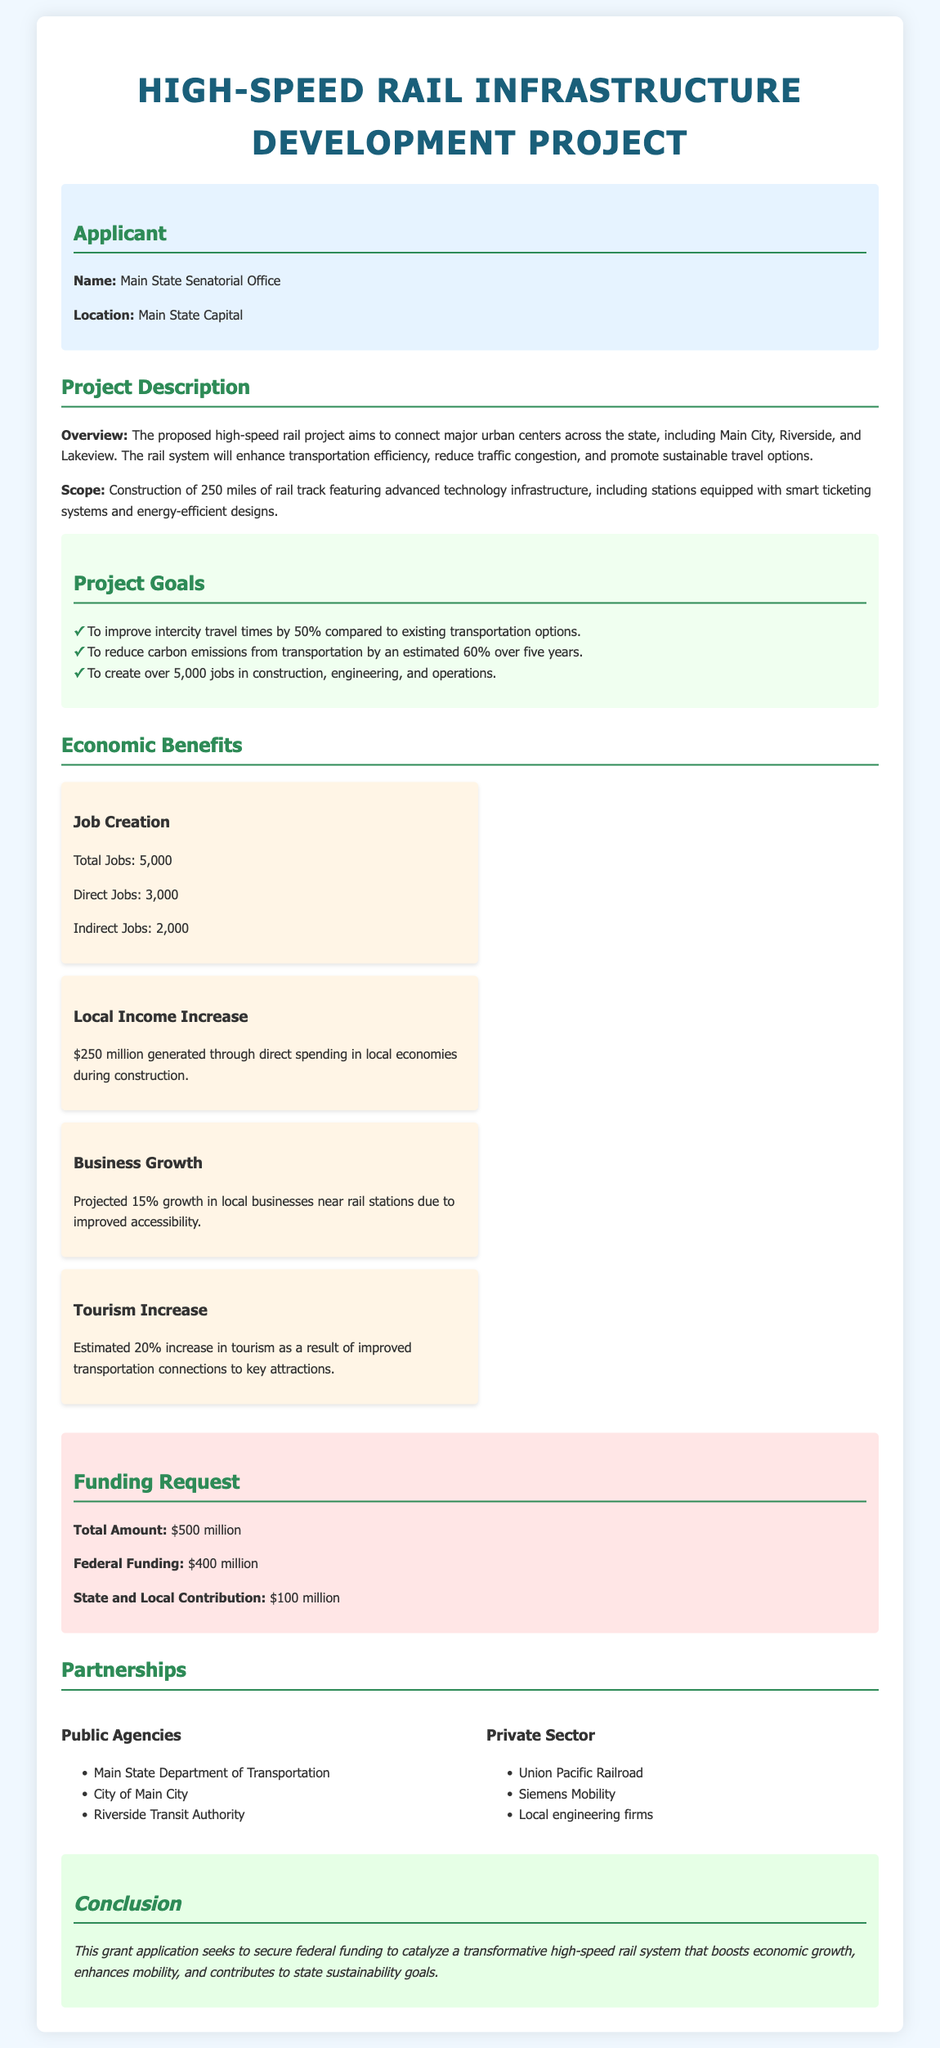What is the name of the applicant? The applicant's name is provided in the document as "Main State Senatorial Office."
Answer: Main State Senatorial Office What is the total funding requested? The total amount requested for the project is clearly stated in the document.
Answer: $500 million How many miles of rail track are proposed to be constructed? The document states the scope of construction involves 250 miles of rail track.
Answer: 250 miles What percentage increase in tourism is estimated? The document indicates an estimated 20% increase in tourism due to the project.
Answer: 20% Which public agency is involved in the project? The document lists several agencies, including the "Main State Department of Transportation."
Answer: Main State Department of Transportation What is the projected job creation for the project? The document outlines the total jobs created as 5,000, including direct and indirect jobs.
Answer: 5,000 What is the local income increase projected? In the document, the projected local income increase through construction is stated as $250 million.
Answer: $250 million What is the federal funding amount requested? The document specifies the amount of federal funding requested as $400 million.
Answer: $400 million What is one goal of the project? The document lists goals, one of which is to improve intercity travel times by 50%.
Answer: Improve intercity travel times by 50% 